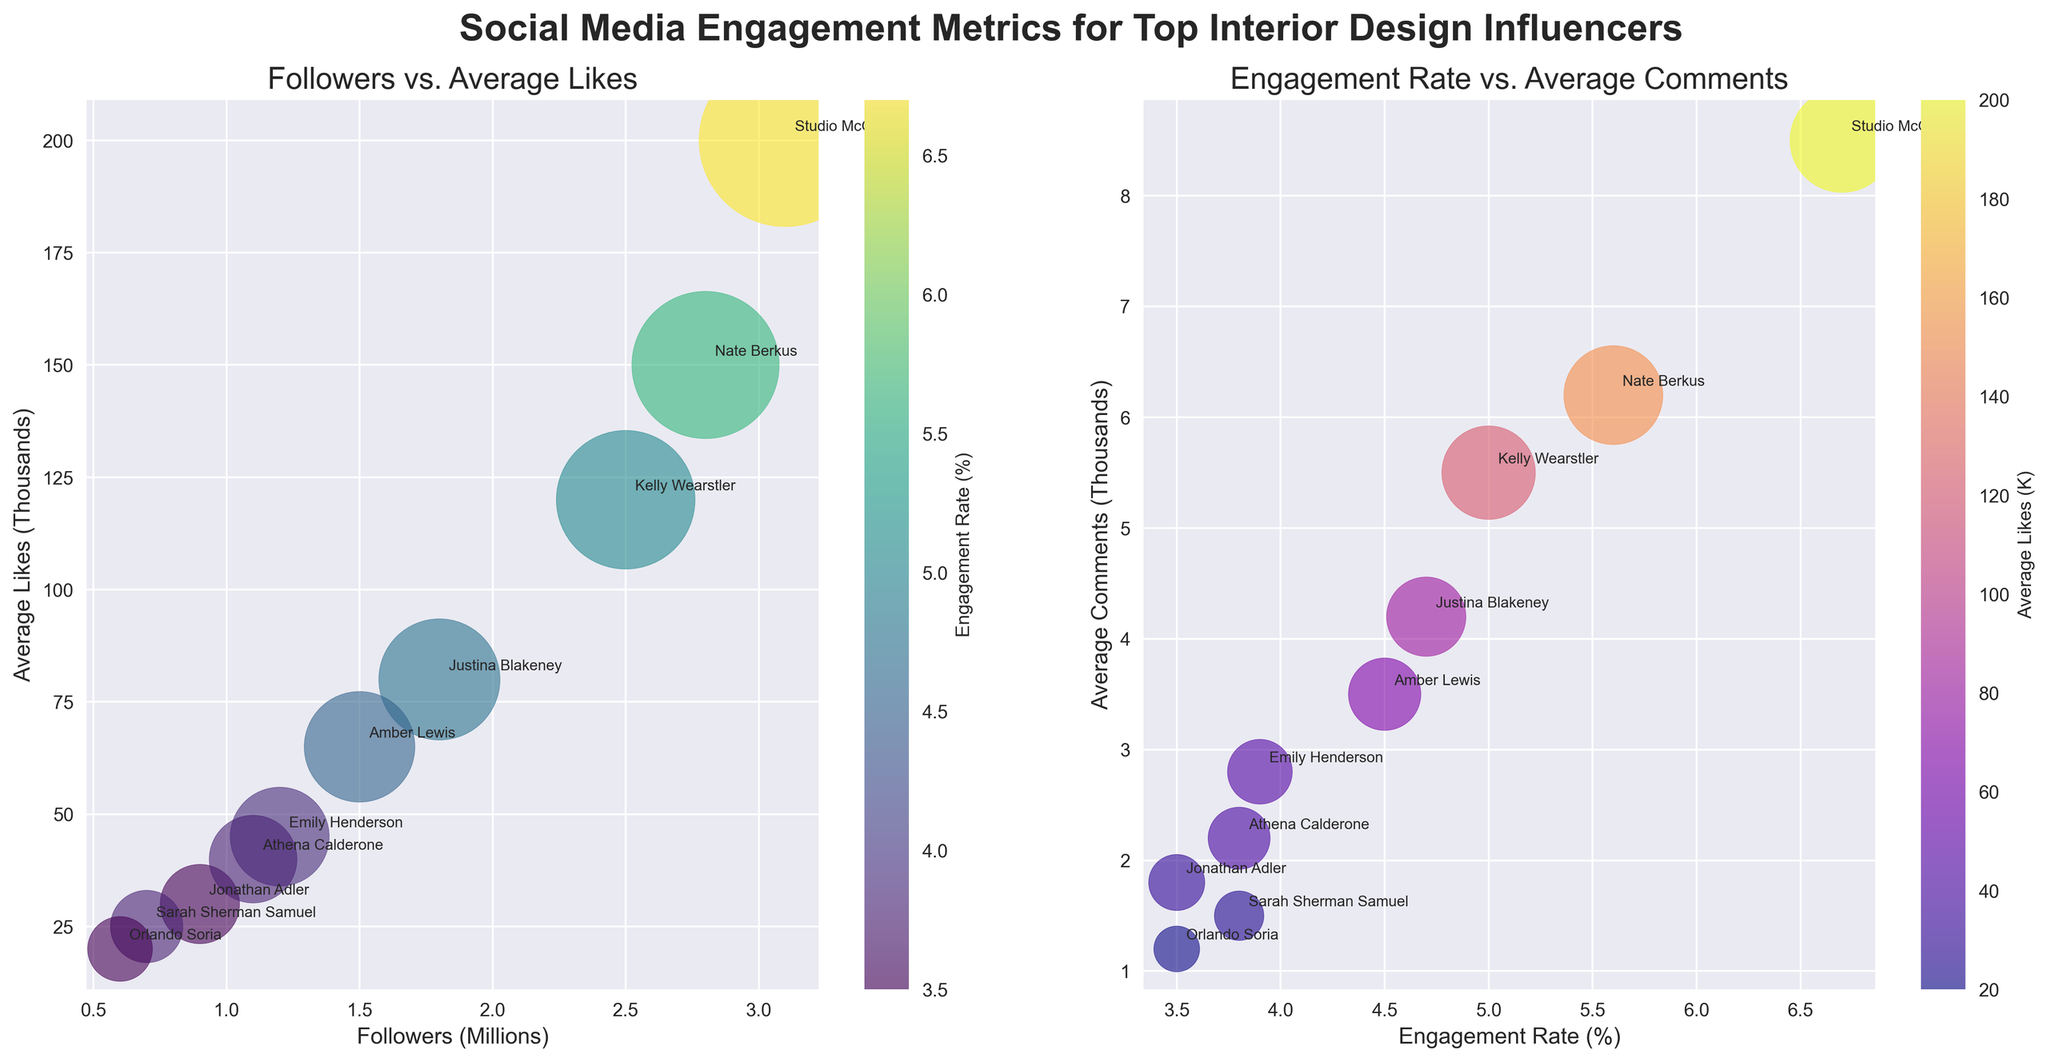What is the title of the first subplot on the left? The first subplot title is the text at the top of the left plot. It reads "Followers vs. Average Likes."
Answer: Followers vs. Average Likes Which influencer has the highest number of followers? In the first subplot, the x-axis represents the number of followers in millions. The data point furthest to the right belongs to Studio McGee.
Answer: Studio McGee What does the size of the bubbles represent in the first subplot? The size of the bubbles in the first subplot represents the average number of comments in thousands. Larger bubbles indicate more comments.
Answer: Average Comments Who has the highest engagement rate according to the second subplot? The second subplot shows engagement rate on the x-axis. The highest value is furthest to the right and the annotation there indicates the influencer Studio McGee has the highest engagement rate.
Answer: Studio McGee Between Emily Henderson and Sarah Sherman Samuel, who has more average likes? In the first subplot, the y-axis represents average likes in thousands. Emily Henderson has a data point higher on the y-axis compared to Sarah Sherman Samuel, indicating more average likes.
Answer: Emily Henderson Which influencer has a higher engagement rate: Kelly Wearstler or Nate Berkus? In the second subplot, engagement rate is plotted on the x-axis. Comparing Kelly Wearstler and Nate Berkus, Nate Berkus's data point is further to the right, indicating a higher engagement rate.
Answer: Nate Berkus Describe the relationship between followers and average likes for Jonathan Adler. Looking at the first subplot, Jonathan Adler is represented by the data point close to (0.9, 30). This indicates that Jonathan Adler has 0.9 million followers and an average of 30,000 likes.
Answer: 0.9 million followers, 30,000 likes Who has the smallest number of average comments and how can you tell? In the first subplot, the smallest bubbles represent fewer average comments. Orlando Soria's bubble (0.6 million followers, 20,000 likes) is the smallest, indicating the least average comments.
Answer: Orlando Soria In the second subplot, which influencer's bubble is colored darkest and what does this indicate? The color of the bubbles in the second subplot represents the average number of likes in thousands. Athena Calderone's bubble is the darkest, indicating she has among the lowest average likes.
Answer: Athena Calderone 